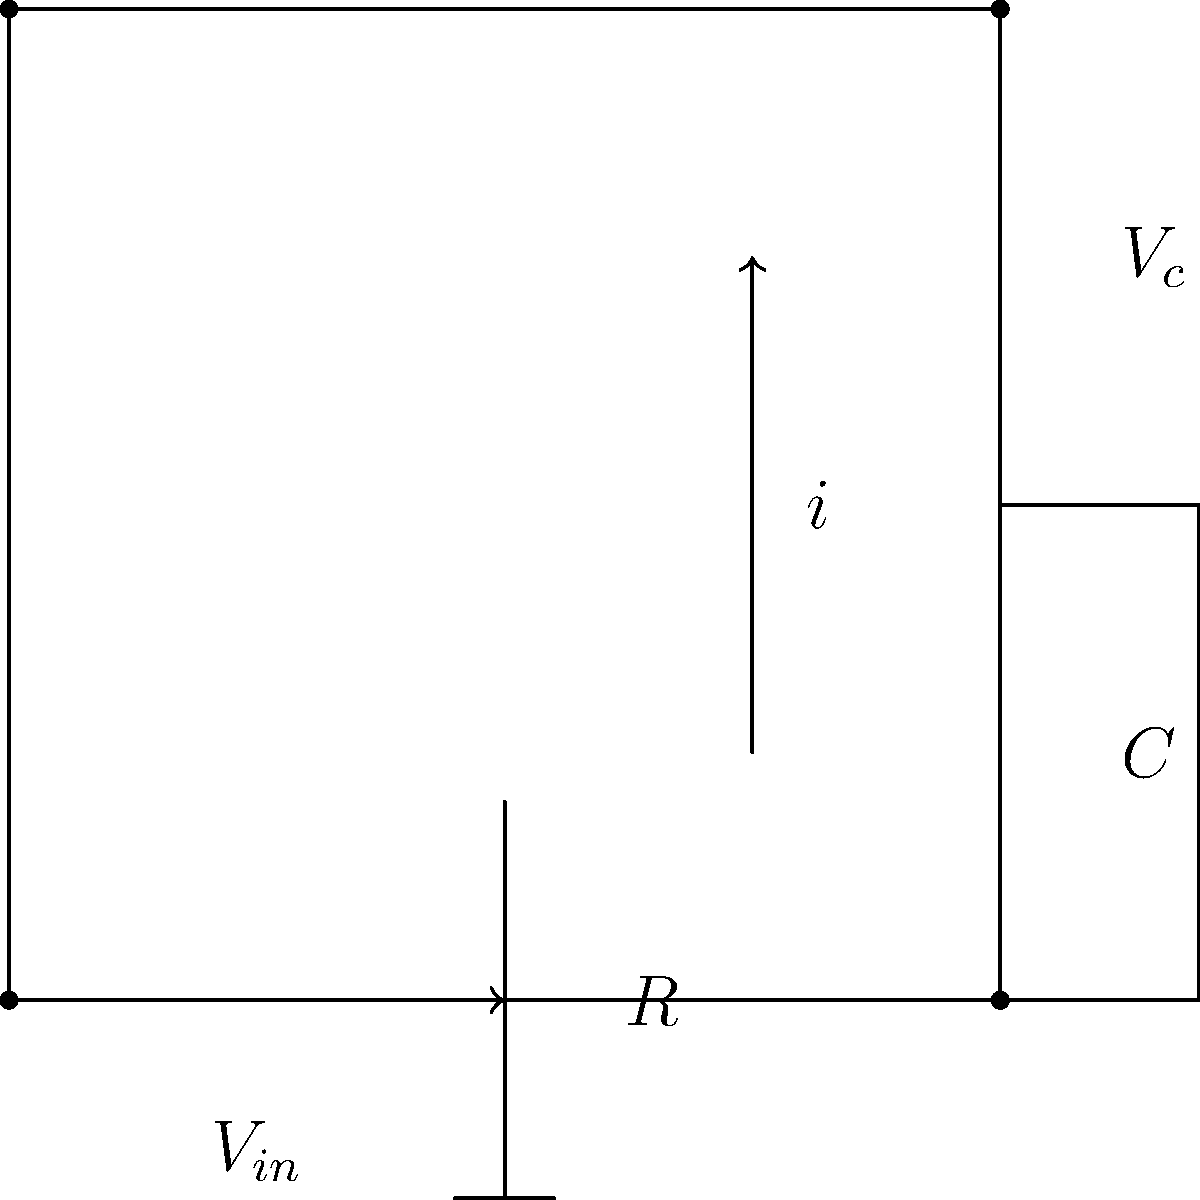In an age discrimination case, you're presented with evidence of a company's outdated equipment affecting older workers' productivity. To understand the technical aspects, you need to analyze a basic RC circuit. Given the circuit diagram, if the input voltage $V_{in}$ is a step function that changes from 0 to 5V at $t=0$, and $R = 10k\Omega$, $C = 100\mu F$, what is the time constant $\tau$ of this circuit? To solve this problem, we need to follow these steps:

1. Recall the formula for the time constant in an RC circuit:
   $\tau = RC$

2. We are given the values:
   $R = 10k\Omega = 10,000\Omega$
   $C = 100\mu F = 100 \times 10^{-6} F$

3. Substitute these values into the formula:
   $\tau = (10,000\Omega) \times (100 \times 10^{-6} F)$

4. Simplify:
   $\tau = 1,000,000 \times 10^{-6} s = 1 s$

Therefore, the time constant of this RC circuit is 1 second.

This time constant represents the time it takes for the capacitor to charge to approximately 63.2% of its final value or discharge to 36.8% of its initial value. In the context of the age discrimination case, understanding this concept could help explain why older workers might appear less productive if they're using equipment with slower response times.
Answer: $\tau = 1$ s 